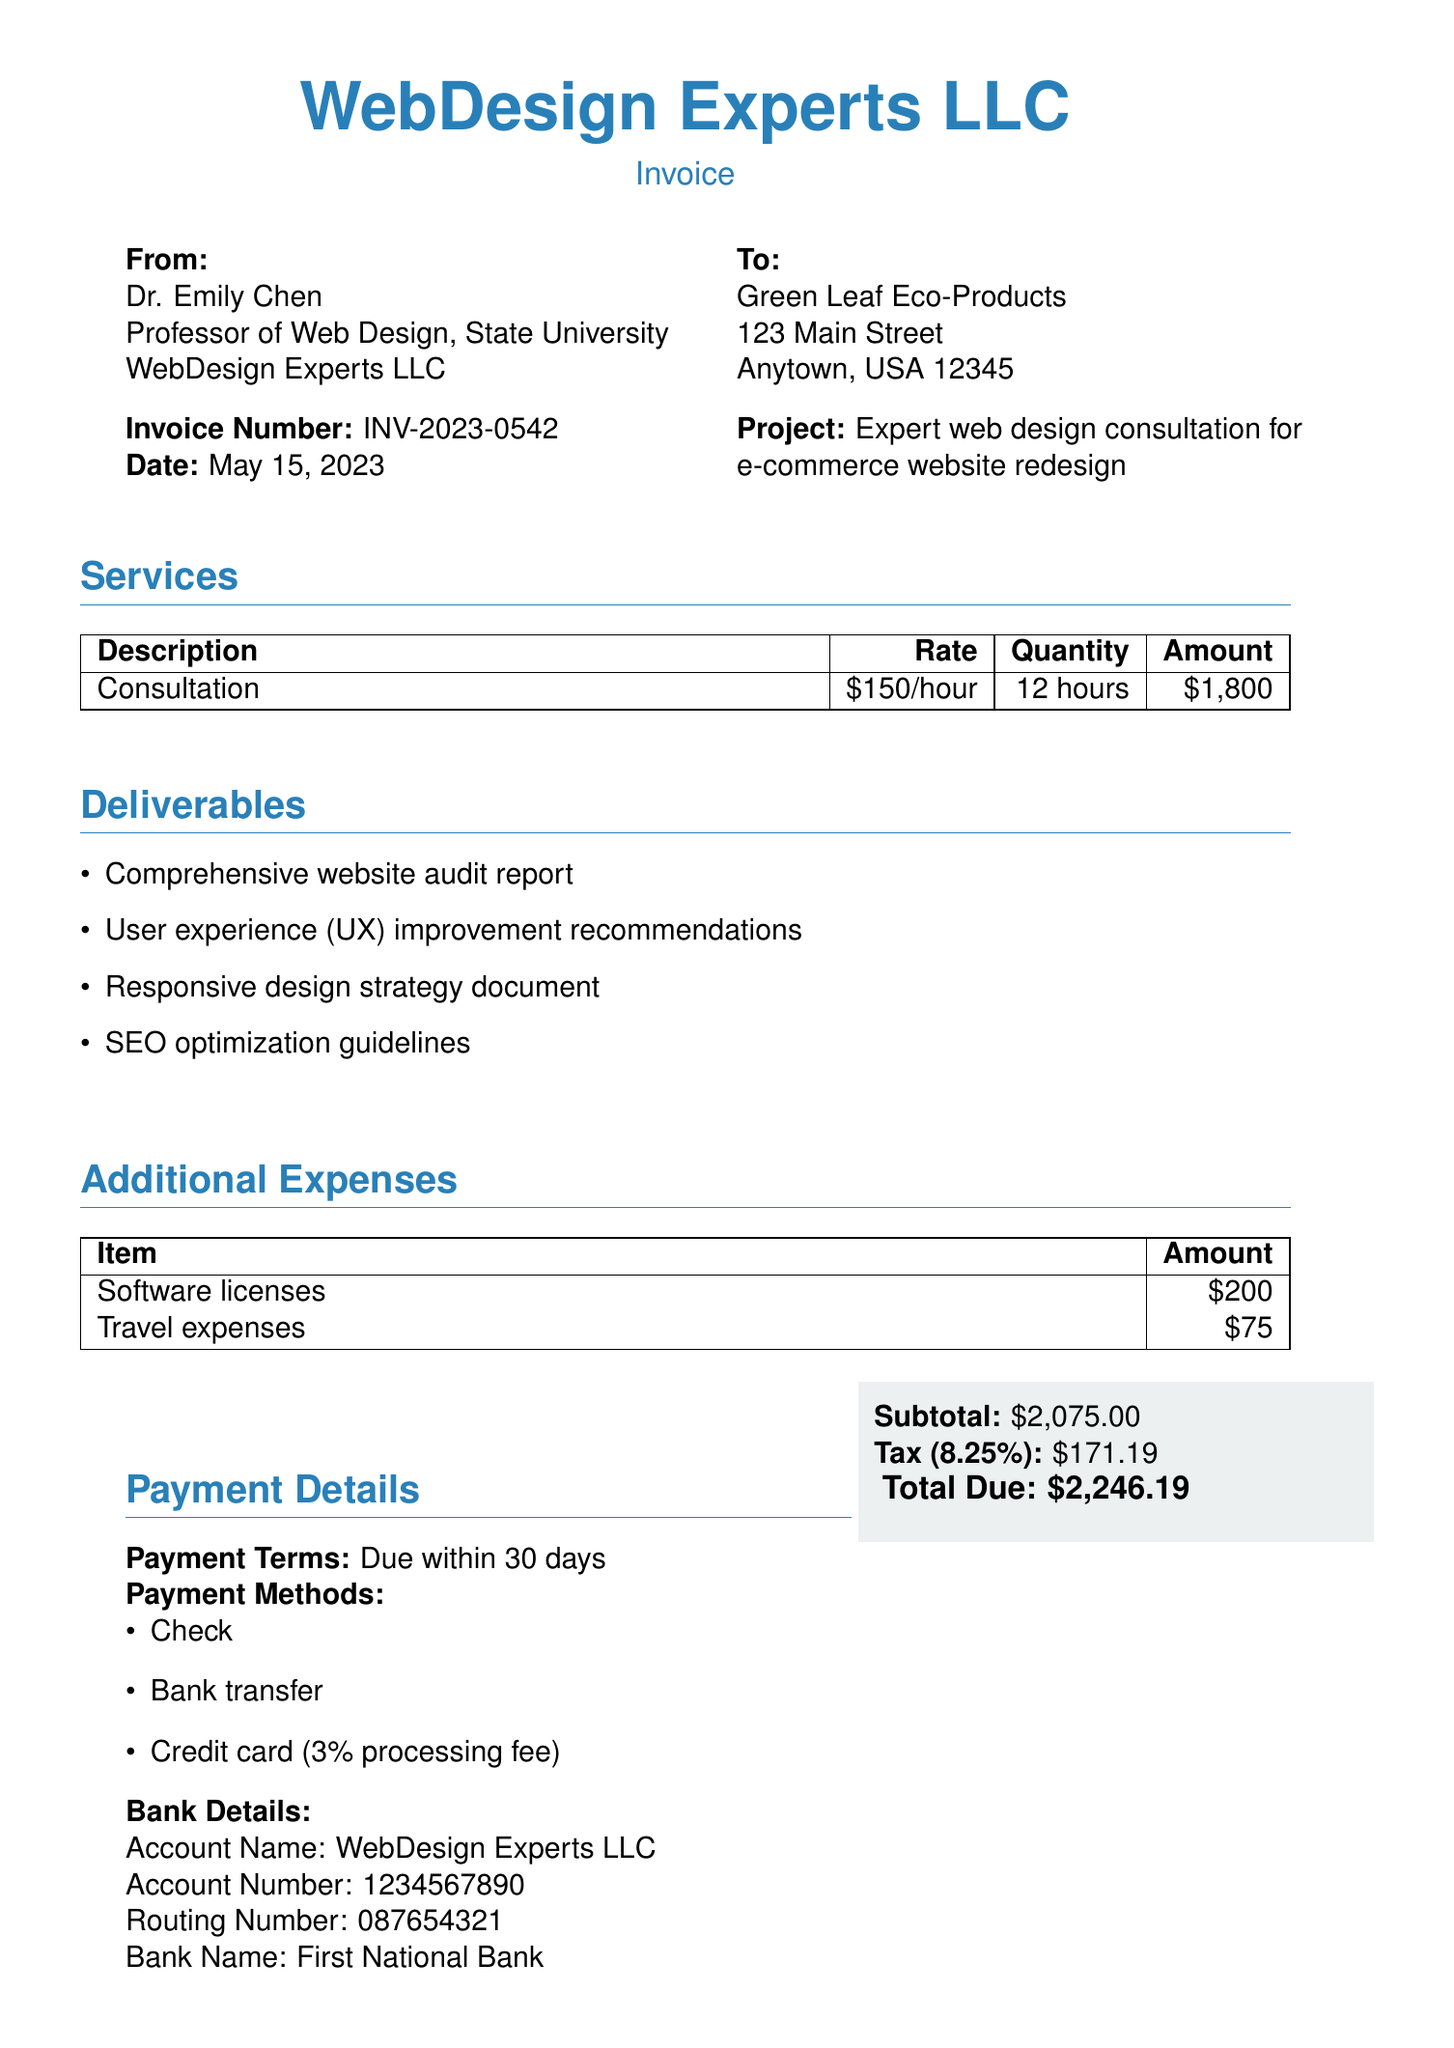What is the invoice number? The invoice number is a unique identifier for this bill, which is listed at the top of the document.
Answer: INV-2023-0542 Who provided the consultation? The name of the person or entity providing the consultation is listed under the "From" section of the invoice.
Answer: Dr. Emily Chen What is the total due amount? The total due amount is presented at the bottom of the invoice after subtotal and tax calculations.
Answer: $2,246.19 How many hours were billed for consultation? The number of hours billed for consultation is specified in the services table of the document.
Answer: 12 hours What are one of the deliverables listed? Deliverables are items that the service provider commits to delivering, listed in the "Deliverables" section of the document.
Answer: Comprehensive website audit report What is the hourly rate for consultation? The hourly rate is mentioned in the services table and indicates the price per hour for the services provided.
Answer: $150/hour What is the tax rate applied to the invoice? The tax rate is provided in the subtotal section and indicates how much tax has been added to the subtotal.
Answer: 8.25% What is the payment term mentioned? The payment term indicates how long the client has to pay the invoice and is listed in the payment details section.
Answer: Due within 30 days 